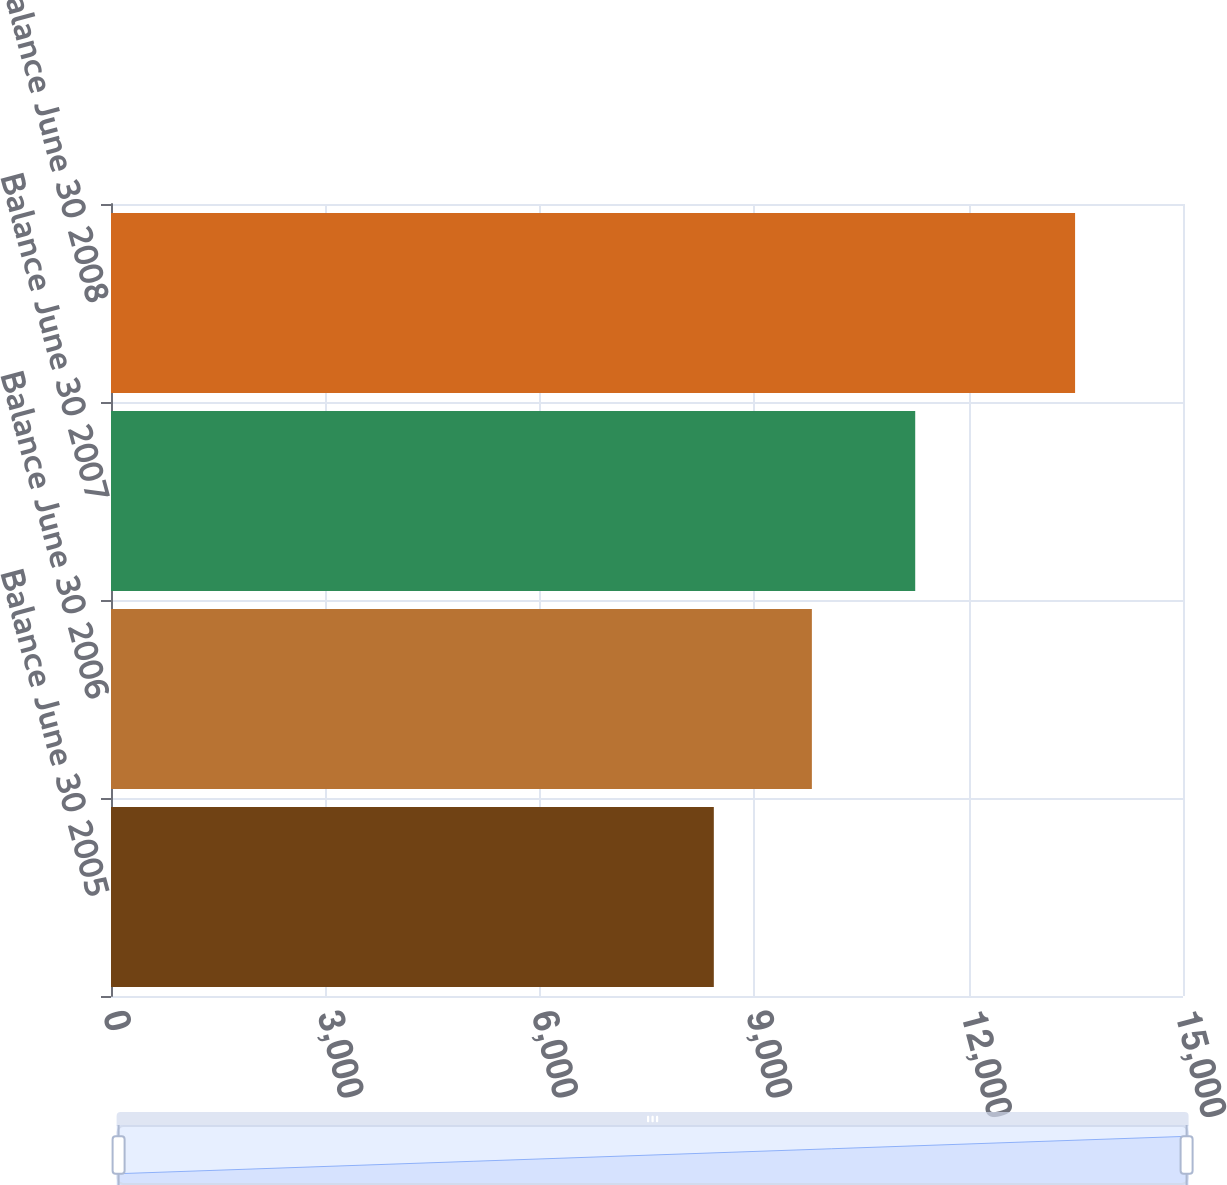Convert chart. <chart><loc_0><loc_0><loc_500><loc_500><bar_chart><fcel>Balance June 30 2005<fcel>Balance June 30 2006<fcel>Balance June 30 2007<fcel>Balance June 30 2008<nl><fcel>8435<fcel>9807<fcel>11253<fcel>13490<nl></chart> 